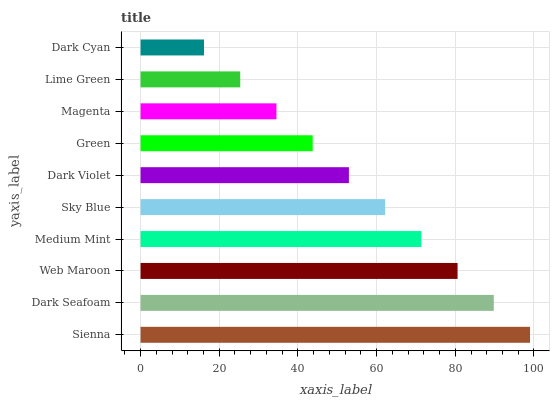Is Dark Cyan the minimum?
Answer yes or no. Yes. Is Sienna the maximum?
Answer yes or no. Yes. Is Dark Seafoam the minimum?
Answer yes or no. No. Is Dark Seafoam the maximum?
Answer yes or no. No. Is Sienna greater than Dark Seafoam?
Answer yes or no. Yes. Is Dark Seafoam less than Sienna?
Answer yes or no. Yes. Is Dark Seafoam greater than Sienna?
Answer yes or no. No. Is Sienna less than Dark Seafoam?
Answer yes or no. No. Is Sky Blue the high median?
Answer yes or no. Yes. Is Dark Violet the low median?
Answer yes or no. Yes. Is Web Maroon the high median?
Answer yes or no. No. Is Dark Cyan the low median?
Answer yes or no. No. 